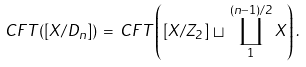<formula> <loc_0><loc_0><loc_500><loc_500>C F T ( [ X / D _ { n } ] ) \, = \, C F T \left ( [ X / { Z } _ { 2 } ] \, \sqcup \, \coprod _ { 1 } ^ { ( n - 1 ) / 2 } X \right ) .</formula> 